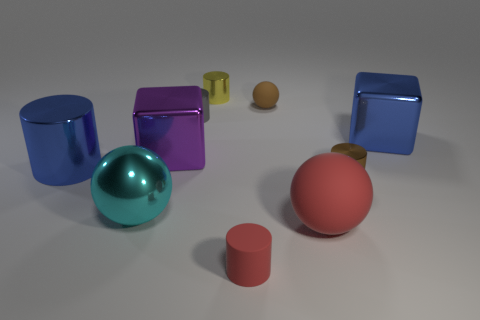Subtract all cubes. How many objects are left? 8 Subtract all brown shiny cylinders. How many cylinders are left? 4 Subtract 1 purple cubes. How many objects are left? 9 Subtract 2 cubes. How many cubes are left? 0 Subtract all purple blocks. Subtract all red cylinders. How many blocks are left? 1 Subtract all cyan cylinders. How many purple cubes are left? 1 Subtract all big shiny blocks. Subtract all metallic cylinders. How many objects are left? 4 Add 3 tiny metallic things. How many tiny metallic things are left? 6 Add 9 green matte cylinders. How many green matte cylinders exist? 9 Subtract all cyan spheres. How many spheres are left? 2 